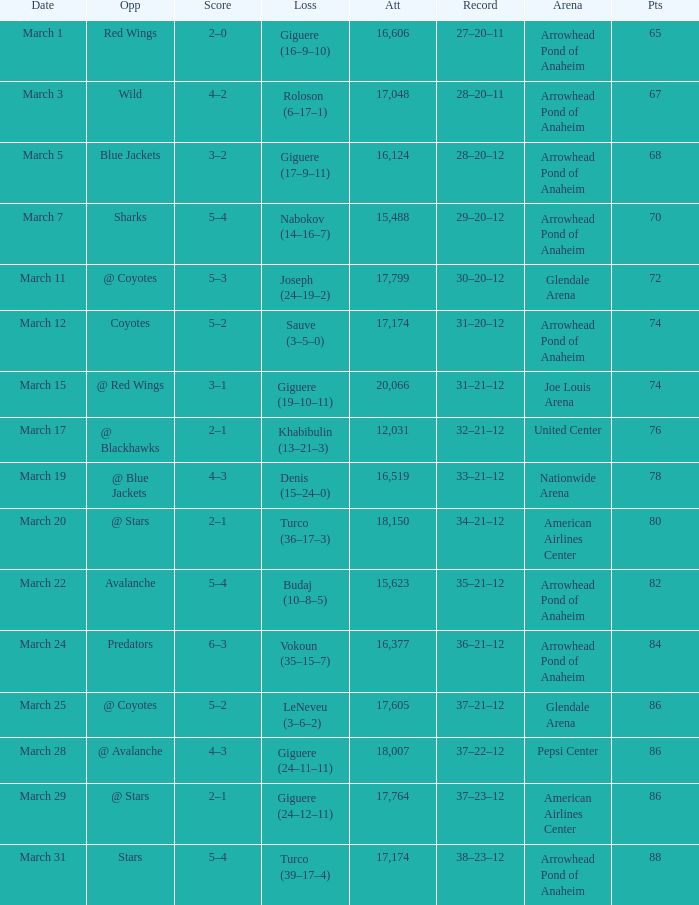What is the number of attendees at joe louis arena? 20066.0. 